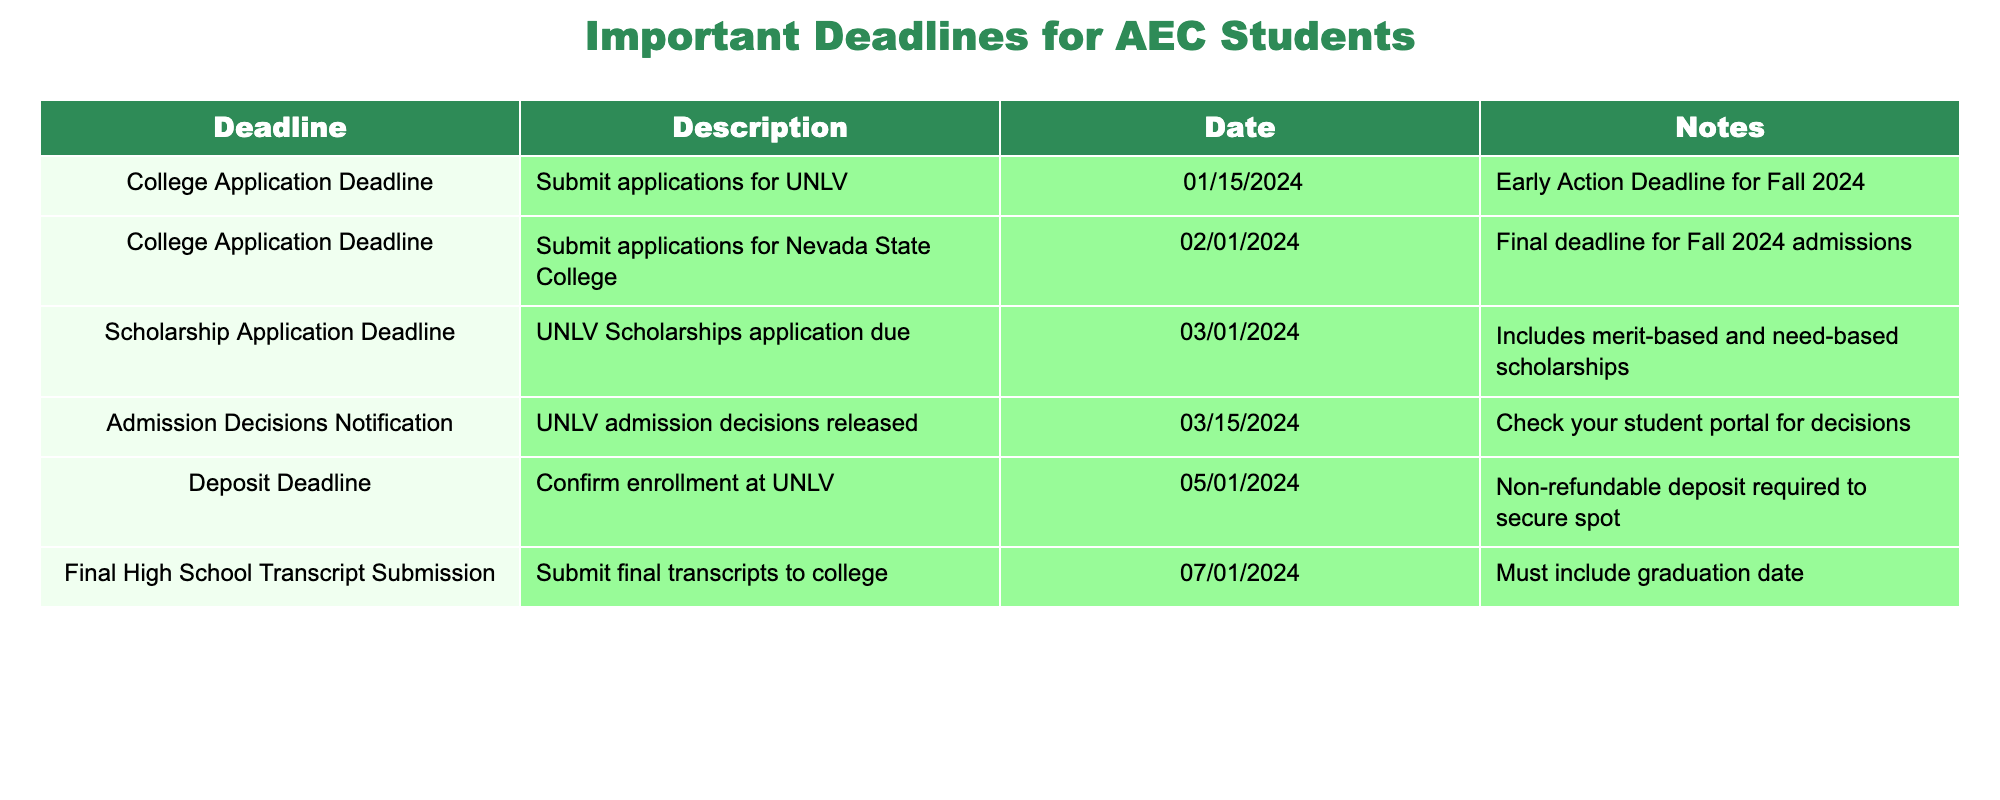What is the deadline to submit applications for UNLV? The table indicates that the deadline to submit applications for UNLV is on 01/15/2024, specifically noted as the Early Action Deadline for Fall 2024 admissions.
Answer: 01/15/2024 What is the final deadline for Nevada State College applications? According to the table, the final deadline for submitting applications for Nevada State College is on 02/01/2024.
Answer: 02/01/2024 Are the deadlines for scholarship applications after the college application deadlines? The scholarship application deadline on 03/01/2024 occurs after the college application deadlines of 01/15/2024 and 02/01/2024, confirming this is true.
Answer: Yes When will UNLV release admission decisions? The table specifies that UNLV will release its admission decisions on 03/15/2024.
Answer: 03/15/2024 If a student enrolls at UNLV, what is the deposit deadline? The table shows that the deposit deadline to confirm enrollment at UNLV is 05/01/2024, indicated as a non-refundable deposit required to secure the spot.
Answer: 05/01/2024 How many deadlines are there listed for scholarship applications and admissions combined? There are a total of three deadlines related to admissions (two for college applications plus one for admission notices) and one for scholarship applications, totaling four deadlines overall.
Answer: 4 Is the final transcript submission deadline before or after the deposit deadline? The final transcript submission deadline is on 07/01/2024, which is after the deposit deadline of 05/01/2024, meaning that the final transcript submission occurs later.
Answer: After What will happen if a student misses the UNLV application deadline? The table does not provide specific consequences of missing the deadline, but the absence of a noted late submission option strongly implies that applications cannot be submitted after the deadline.
Answer: Not specified What is the earliest application-related deadline for the listed colleges? The earliest application deadline listed in the table is for UNLV, which is on 01/15/2024, indicating it is the first application-related deadline.
Answer: 01/15/2024 